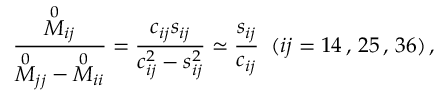<formula> <loc_0><loc_0><loc_500><loc_500>\frac { { \stackrel { 0 } { M } } _ { i j } } { { \stackrel { 0 } { M } } _ { j j } - { \stackrel { 0 } { M } } _ { i i } } = \frac { c _ { i j } s _ { i j } } { c _ { i j } ^ { 2 } - s _ { i j } ^ { 2 } } \simeq \frac { s _ { i j } } { c _ { i j } } \, ( i j = 1 4 \, , \, 2 5 \, , \, 3 6 ) \, ,</formula> 